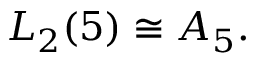Convert formula to latex. <formula><loc_0><loc_0><loc_500><loc_500>L _ { 2 } ( 5 ) \cong A _ { 5 } .</formula> 